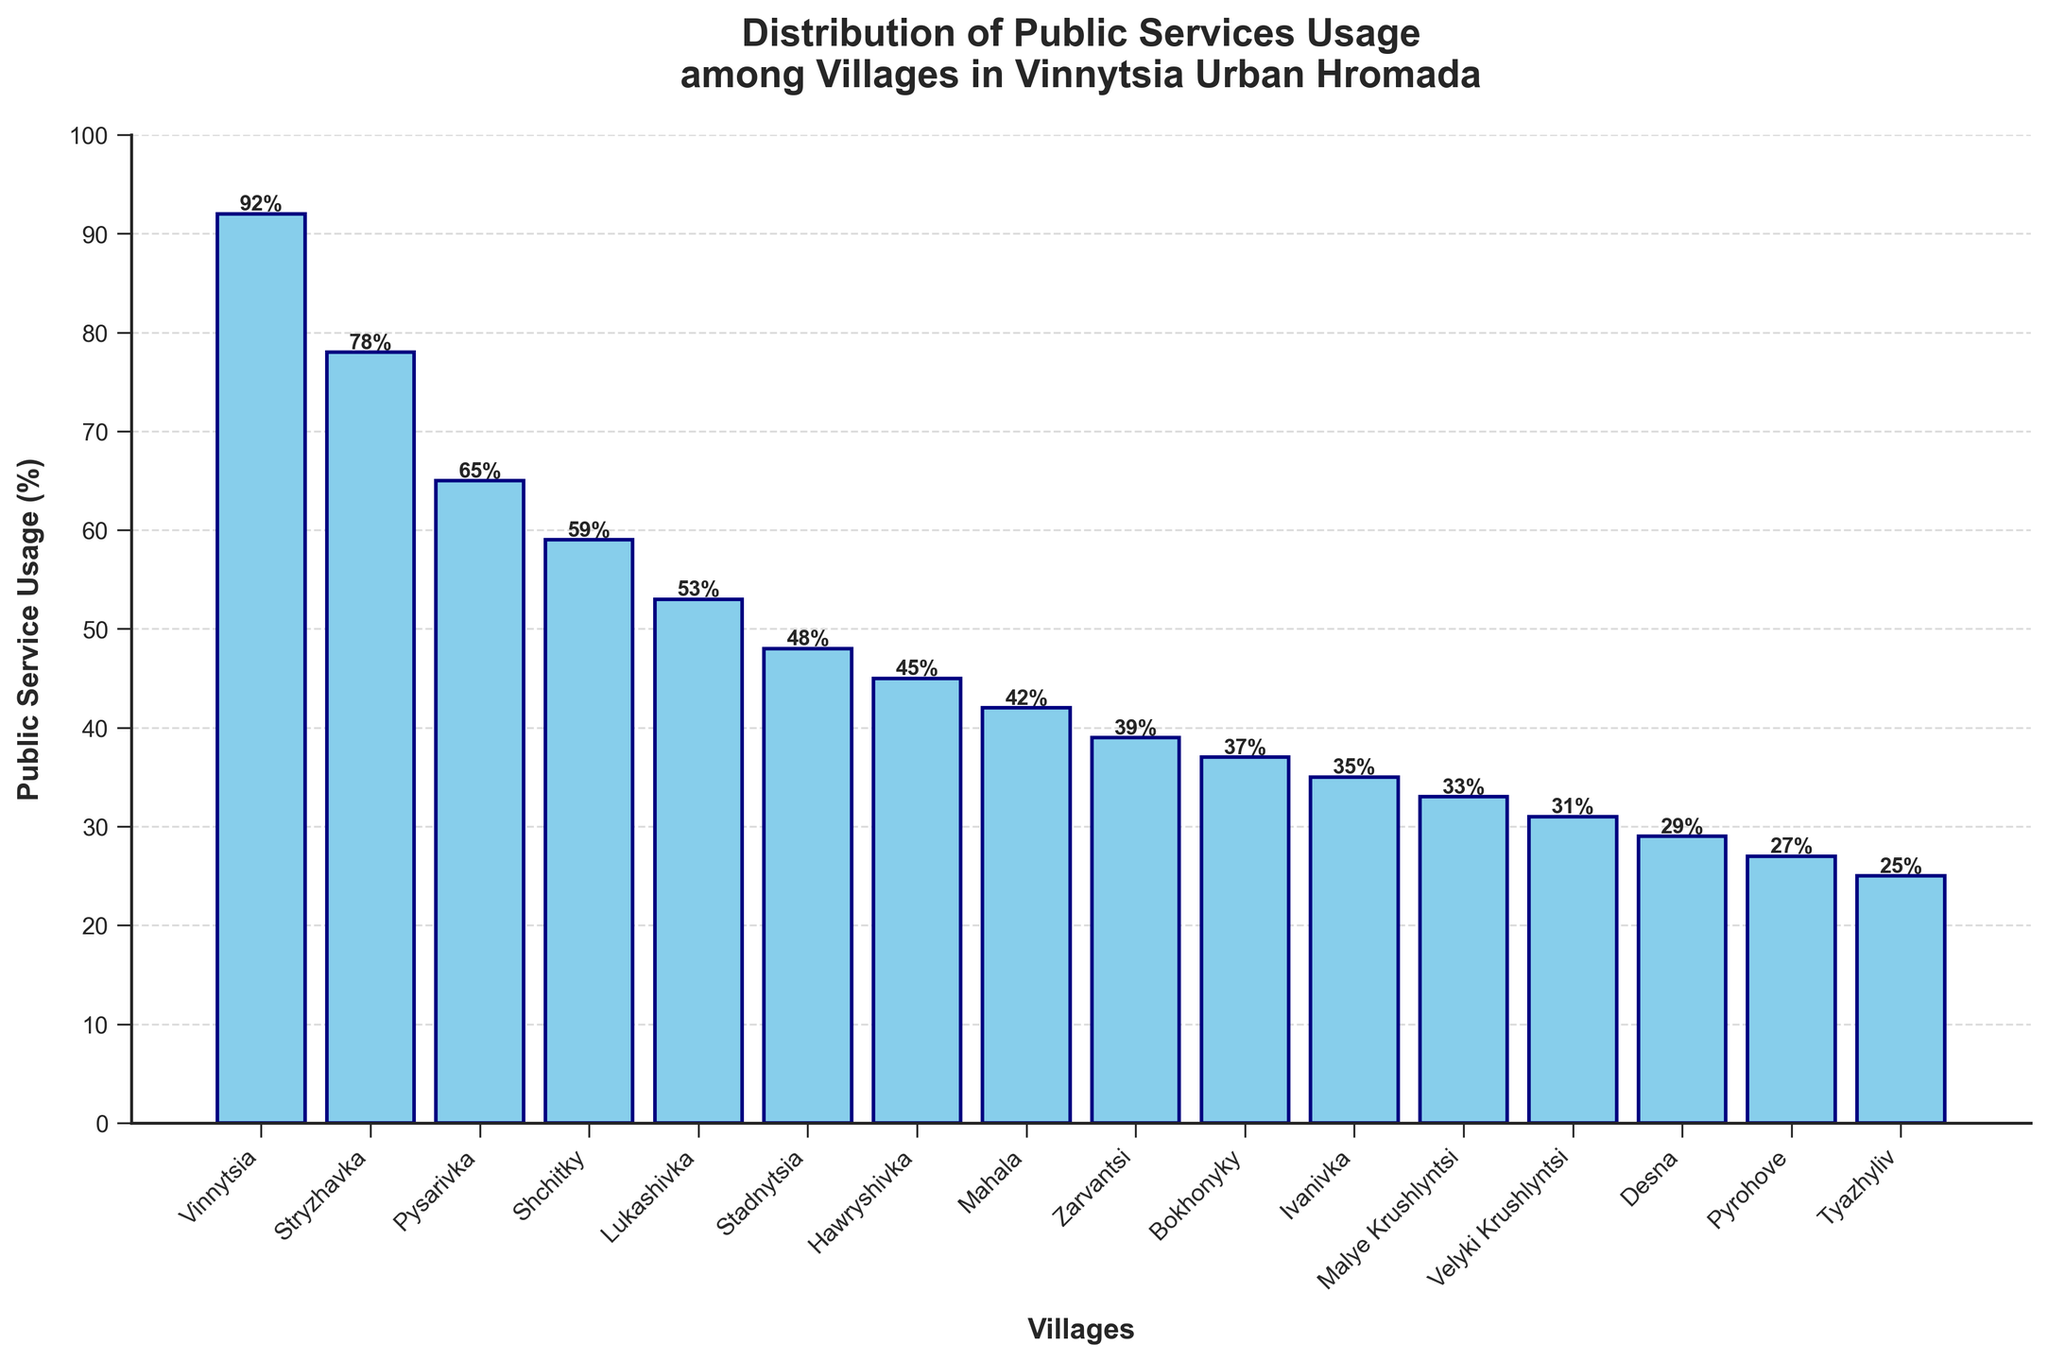which village has the highest public service usage? The highest bar in the plot represents Vinnytsia village which has a public service usage of 92%.
Answer: Vinnytsia how many villages have a public service usage above 50%? Observing the heights of the bars above the 50% mark, we can count that five villages exceed this value: Vinnytsia, Stryzhavka, Pysarivka, Shchitky, and Lukashivka.
Answer: 5 what is the difference in public service usage between the top and bottom village? The highest public service usage is in Vinnytsia (92%) and the lowest is in Tyazhyliv (25%). The difference is 92 - 25 = 67%.
Answer: 67% which village has the lowest public service usage and what percentage is it? The lowest bar in the plot represents Tyazhyliv village with a public service usage of 25%.
Answer: Tyazhyliv, 25% compare the public service usage between Stryzhavka and Malye Krushlyntsi Stryzhavka has a usage of 78%, while Malye Krushlyntsi has a usage of 33%. Therefore, Stryzhavka has a higher public service usage compared to Malye Krushlyntsi.
Answer: Stryzhavka > Malye Krushlyntsi what is the average public service usage of villages with usage less than 40%? The villages are Mahala (42%), Zarvantsi (39%), Bokhonyky (37%), Ivanivka (35%), Malye Krushlyntsi (33%), Velyki Krushlyntsi (31%), Desna (29%), and Pyrohovе (27%). The average is calculated as (39 + 37 + 35 + 33 + 31 + 29 + 27) / 7 ≈ 33. See that Mahala (42%) is not considered because it is not less than 40.
Answer: 33 what is the median public service usage? To find the median, list the percentages in ascending order: 25, 27, 29, 31, 33, 35, 37, 39, 42, 45, 48, 53, 59, 65, 78, 92. The median is the average of the 8th and 9th values: (39 + 42) / 2 = 40.5%
Answer: 40.5 is the average public service usage among all the villages more or less than 50%? To find the average of all the villages, add the percentages and divide by the number of villages: (92 + 78 + 65 + 59 + 53 + 48 + 45 + 42 + 39 + 37 + 35 + 33 + 31 + 29 + 27 + 25) / 16 = 46.125%. This value is less than 50%.
Answer: Less which village has a public service usage closest to 40%? The village Zarvantsi has a usage closest to 40%, specifically 39%.
Answer: Zarvantsi what is the total public service usage of the top three villages? The top three villages in usage are Vinnytsia (92%), Stryzhavka (78%), and Pysarivka (65%). The total is 92 + 78 + 65 = 235%.
Answer: 235 